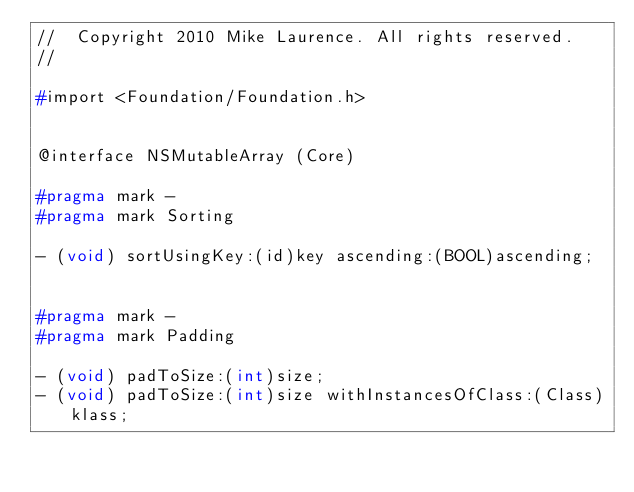Convert code to text. <code><loc_0><loc_0><loc_500><loc_500><_C_>//  Copyright 2010 Mike Laurence. All rights reserved.
//

#import <Foundation/Foundation.h>


@interface NSMutableArray (Core)

#pragma mark -
#pragma mark Sorting

- (void) sortUsingKey:(id)key ascending:(BOOL)ascending;


#pragma mark -
#pragma mark Padding

- (void) padToSize:(int)size;
- (void) padToSize:(int)size withInstancesOfClass:(Class)klass;</code> 